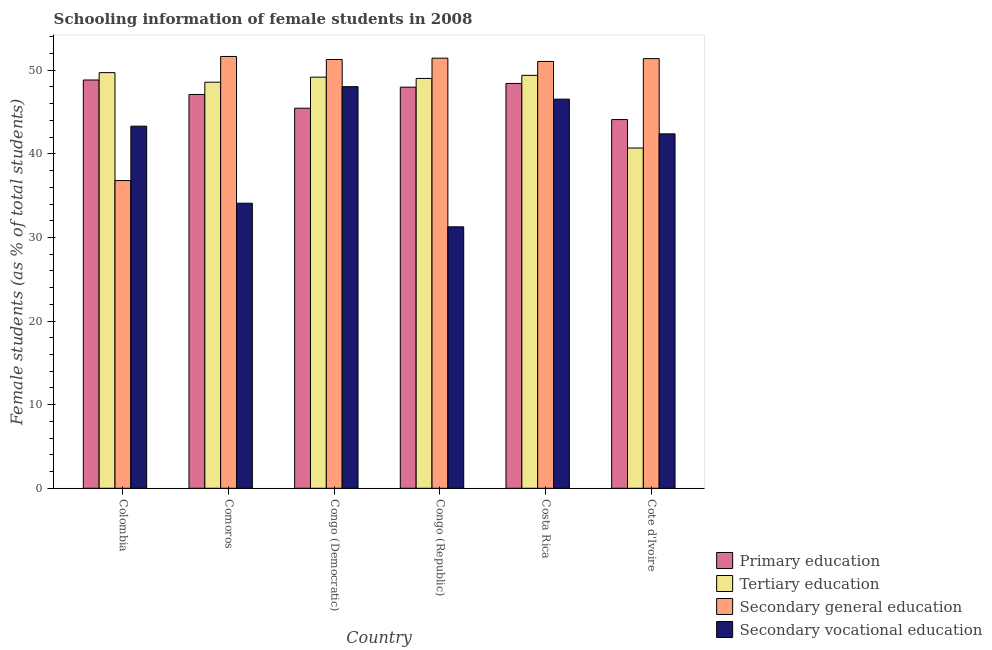How many bars are there on the 5th tick from the left?
Give a very brief answer. 4. How many bars are there on the 6th tick from the right?
Your answer should be compact. 4. What is the label of the 4th group of bars from the left?
Provide a succinct answer. Congo (Republic). What is the percentage of female students in primary education in Cote d'Ivoire?
Your answer should be compact. 44.1. Across all countries, what is the maximum percentage of female students in secondary education?
Provide a succinct answer. 51.65. Across all countries, what is the minimum percentage of female students in secondary education?
Your response must be concise. 36.81. In which country was the percentage of female students in secondary education maximum?
Provide a short and direct response. Comoros. In which country was the percentage of female students in secondary vocational education minimum?
Offer a terse response. Congo (Republic). What is the total percentage of female students in primary education in the graph?
Provide a short and direct response. 281.9. What is the difference between the percentage of female students in primary education in Comoros and that in Cote d'Ivoire?
Give a very brief answer. 3. What is the difference between the percentage of female students in tertiary education in Congo (Republic) and the percentage of female students in secondary vocational education in Comoros?
Offer a terse response. 14.92. What is the average percentage of female students in tertiary education per country?
Keep it short and to the point. 47.76. What is the difference between the percentage of female students in secondary vocational education and percentage of female students in primary education in Congo (Democratic)?
Provide a short and direct response. 2.58. In how many countries, is the percentage of female students in primary education greater than 48 %?
Keep it short and to the point. 2. What is the ratio of the percentage of female students in secondary education in Congo (Democratic) to that in Congo (Republic)?
Make the answer very short. 1. Is the percentage of female students in tertiary education in Costa Rica less than that in Cote d'Ivoire?
Give a very brief answer. No. What is the difference between the highest and the second highest percentage of female students in secondary education?
Provide a succinct answer. 0.2. What is the difference between the highest and the lowest percentage of female students in primary education?
Offer a very short reply. 4.73. In how many countries, is the percentage of female students in tertiary education greater than the average percentage of female students in tertiary education taken over all countries?
Offer a very short reply. 5. What does the 2nd bar from the left in Congo (Republic) represents?
Your answer should be compact. Tertiary education. What does the 3rd bar from the right in Cote d'Ivoire represents?
Ensure brevity in your answer.  Tertiary education. Is it the case that in every country, the sum of the percentage of female students in primary education and percentage of female students in tertiary education is greater than the percentage of female students in secondary education?
Give a very brief answer. Yes. What is the difference between two consecutive major ticks on the Y-axis?
Make the answer very short. 10. Are the values on the major ticks of Y-axis written in scientific E-notation?
Ensure brevity in your answer.  No. Does the graph contain any zero values?
Ensure brevity in your answer.  No. What is the title of the graph?
Your answer should be compact. Schooling information of female students in 2008. Does "Greece" appear as one of the legend labels in the graph?
Offer a terse response. No. What is the label or title of the Y-axis?
Make the answer very short. Female students (as % of total students). What is the Female students (as % of total students) of Primary education in Colombia?
Offer a terse response. 48.84. What is the Female students (as % of total students) in Tertiary education in Colombia?
Provide a succinct answer. 49.72. What is the Female students (as % of total students) in Secondary general education in Colombia?
Your answer should be very brief. 36.81. What is the Female students (as % of total students) of Secondary vocational education in Colombia?
Your answer should be very brief. 43.31. What is the Female students (as % of total students) in Primary education in Comoros?
Give a very brief answer. 47.1. What is the Female students (as % of total students) in Tertiary education in Comoros?
Offer a terse response. 48.58. What is the Female students (as % of total students) in Secondary general education in Comoros?
Your response must be concise. 51.65. What is the Female students (as % of total students) in Secondary vocational education in Comoros?
Keep it short and to the point. 34.1. What is the Female students (as % of total students) of Primary education in Congo (Democratic)?
Provide a succinct answer. 45.46. What is the Female students (as % of total students) of Tertiary education in Congo (Democratic)?
Give a very brief answer. 49.18. What is the Female students (as % of total students) in Secondary general education in Congo (Democratic)?
Offer a very short reply. 51.29. What is the Female students (as % of total students) in Secondary vocational education in Congo (Democratic)?
Your answer should be compact. 48.04. What is the Female students (as % of total students) of Primary education in Congo (Republic)?
Give a very brief answer. 47.98. What is the Female students (as % of total students) in Tertiary education in Congo (Republic)?
Your answer should be very brief. 49.02. What is the Female students (as % of total students) in Secondary general education in Congo (Republic)?
Ensure brevity in your answer.  51.45. What is the Female students (as % of total students) of Secondary vocational education in Congo (Republic)?
Your answer should be very brief. 31.27. What is the Female students (as % of total students) of Primary education in Costa Rica?
Keep it short and to the point. 48.42. What is the Female students (as % of total students) of Tertiary education in Costa Rica?
Your answer should be compact. 49.39. What is the Female students (as % of total students) in Secondary general education in Costa Rica?
Provide a succinct answer. 51.05. What is the Female students (as % of total students) in Secondary vocational education in Costa Rica?
Provide a succinct answer. 46.54. What is the Female students (as % of total students) in Primary education in Cote d'Ivoire?
Keep it short and to the point. 44.1. What is the Female students (as % of total students) of Tertiary education in Cote d'Ivoire?
Provide a short and direct response. 40.7. What is the Female students (as % of total students) of Secondary general education in Cote d'Ivoire?
Offer a very short reply. 51.39. What is the Female students (as % of total students) of Secondary vocational education in Cote d'Ivoire?
Keep it short and to the point. 42.39. Across all countries, what is the maximum Female students (as % of total students) in Primary education?
Provide a short and direct response. 48.84. Across all countries, what is the maximum Female students (as % of total students) in Tertiary education?
Your answer should be very brief. 49.72. Across all countries, what is the maximum Female students (as % of total students) of Secondary general education?
Your answer should be very brief. 51.65. Across all countries, what is the maximum Female students (as % of total students) of Secondary vocational education?
Offer a terse response. 48.04. Across all countries, what is the minimum Female students (as % of total students) of Primary education?
Offer a terse response. 44.1. Across all countries, what is the minimum Female students (as % of total students) in Tertiary education?
Your answer should be compact. 40.7. Across all countries, what is the minimum Female students (as % of total students) of Secondary general education?
Provide a short and direct response. 36.81. Across all countries, what is the minimum Female students (as % of total students) in Secondary vocational education?
Offer a terse response. 31.27. What is the total Female students (as % of total students) of Primary education in the graph?
Make the answer very short. 281.9. What is the total Female students (as % of total students) in Tertiary education in the graph?
Offer a very short reply. 286.58. What is the total Female students (as % of total students) in Secondary general education in the graph?
Give a very brief answer. 293.63. What is the total Female students (as % of total students) of Secondary vocational education in the graph?
Make the answer very short. 245.66. What is the difference between the Female students (as % of total students) of Primary education in Colombia and that in Comoros?
Offer a terse response. 1.73. What is the difference between the Female students (as % of total students) in Tertiary education in Colombia and that in Comoros?
Provide a short and direct response. 1.14. What is the difference between the Female students (as % of total students) in Secondary general education in Colombia and that in Comoros?
Your answer should be very brief. -14.84. What is the difference between the Female students (as % of total students) in Secondary vocational education in Colombia and that in Comoros?
Provide a short and direct response. 9.21. What is the difference between the Female students (as % of total students) in Primary education in Colombia and that in Congo (Democratic)?
Ensure brevity in your answer.  3.37. What is the difference between the Female students (as % of total students) in Tertiary education in Colombia and that in Congo (Democratic)?
Your response must be concise. 0.54. What is the difference between the Female students (as % of total students) of Secondary general education in Colombia and that in Congo (Democratic)?
Keep it short and to the point. -14.48. What is the difference between the Female students (as % of total students) of Secondary vocational education in Colombia and that in Congo (Democratic)?
Make the answer very short. -4.73. What is the difference between the Female students (as % of total students) in Primary education in Colombia and that in Congo (Republic)?
Offer a very short reply. 0.86. What is the difference between the Female students (as % of total students) of Tertiary education in Colombia and that in Congo (Republic)?
Keep it short and to the point. 0.7. What is the difference between the Female students (as % of total students) of Secondary general education in Colombia and that in Congo (Republic)?
Provide a short and direct response. -14.64. What is the difference between the Female students (as % of total students) of Secondary vocational education in Colombia and that in Congo (Republic)?
Offer a very short reply. 12.04. What is the difference between the Female students (as % of total students) in Primary education in Colombia and that in Costa Rica?
Ensure brevity in your answer.  0.41. What is the difference between the Female students (as % of total students) of Tertiary education in Colombia and that in Costa Rica?
Provide a succinct answer. 0.33. What is the difference between the Female students (as % of total students) in Secondary general education in Colombia and that in Costa Rica?
Give a very brief answer. -14.25. What is the difference between the Female students (as % of total students) of Secondary vocational education in Colombia and that in Costa Rica?
Give a very brief answer. -3.23. What is the difference between the Female students (as % of total students) of Primary education in Colombia and that in Cote d'Ivoire?
Give a very brief answer. 4.73. What is the difference between the Female students (as % of total students) of Tertiary education in Colombia and that in Cote d'Ivoire?
Offer a terse response. 9.02. What is the difference between the Female students (as % of total students) of Secondary general education in Colombia and that in Cote d'Ivoire?
Give a very brief answer. -14.59. What is the difference between the Female students (as % of total students) of Secondary vocational education in Colombia and that in Cote d'Ivoire?
Your answer should be very brief. 0.92. What is the difference between the Female students (as % of total students) of Primary education in Comoros and that in Congo (Democratic)?
Your answer should be very brief. 1.64. What is the difference between the Female students (as % of total students) of Tertiary education in Comoros and that in Congo (Democratic)?
Offer a terse response. -0.6. What is the difference between the Female students (as % of total students) of Secondary general education in Comoros and that in Congo (Democratic)?
Your response must be concise. 0.36. What is the difference between the Female students (as % of total students) of Secondary vocational education in Comoros and that in Congo (Democratic)?
Provide a short and direct response. -13.94. What is the difference between the Female students (as % of total students) in Primary education in Comoros and that in Congo (Republic)?
Offer a very short reply. -0.87. What is the difference between the Female students (as % of total students) in Tertiary education in Comoros and that in Congo (Republic)?
Provide a short and direct response. -0.45. What is the difference between the Female students (as % of total students) of Secondary general education in Comoros and that in Congo (Republic)?
Offer a very short reply. 0.2. What is the difference between the Female students (as % of total students) in Secondary vocational education in Comoros and that in Congo (Republic)?
Give a very brief answer. 2.82. What is the difference between the Female students (as % of total students) of Primary education in Comoros and that in Costa Rica?
Your answer should be compact. -1.32. What is the difference between the Female students (as % of total students) in Tertiary education in Comoros and that in Costa Rica?
Ensure brevity in your answer.  -0.81. What is the difference between the Female students (as % of total students) in Secondary general education in Comoros and that in Costa Rica?
Provide a short and direct response. 0.6. What is the difference between the Female students (as % of total students) of Secondary vocational education in Comoros and that in Costa Rica?
Your answer should be very brief. -12.45. What is the difference between the Female students (as % of total students) in Primary education in Comoros and that in Cote d'Ivoire?
Your response must be concise. 3. What is the difference between the Female students (as % of total students) of Tertiary education in Comoros and that in Cote d'Ivoire?
Ensure brevity in your answer.  7.88. What is the difference between the Female students (as % of total students) of Secondary general education in Comoros and that in Cote d'Ivoire?
Offer a terse response. 0.26. What is the difference between the Female students (as % of total students) of Secondary vocational education in Comoros and that in Cote d'Ivoire?
Your answer should be very brief. -8.3. What is the difference between the Female students (as % of total students) of Primary education in Congo (Democratic) and that in Congo (Republic)?
Your response must be concise. -2.52. What is the difference between the Female students (as % of total students) of Tertiary education in Congo (Democratic) and that in Congo (Republic)?
Your response must be concise. 0.16. What is the difference between the Female students (as % of total students) of Secondary general education in Congo (Democratic) and that in Congo (Republic)?
Give a very brief answer. -0.16. What is the difference between the Female students (as % of total students) in Secondary vocational education in Congo (Democratic) and that in Congo (Republic)?
Provide a short and direct response. 16.76. What is the difference between the Female students (as % of total students) in Primary education in Congo (Democratic) and that in Costa Rica?
Give a very brief answer. -2.96. What is the difference between the Female students (as % of total students) of Tertiary education in Congo (Democratic) and that in Costa Rica?
Give a very brief answer. -0.21. What is the difference between the Female students (as % of total students) in Secondary general education in Congo (Democratic) and that in Costa Rica?
Keep it short and to the point. 0.23. What is the difference between the Female students (as % of total students) of Secondary vocational education in Congo (Democratic) and that in Costa Rica?
Your response must be concise. 1.49. What is the difference between the Female students (as % of total students) in Primary education in Congo (Democratic) and that in Cote d'Ivoire?
Provide a short and direct response. 1.36. What is the difference between the Female students (as % of total students) of Tertiary education in Congo (Democratic) and that in Cote d'Ivoire?
Keep it short and to the point. 8.48. What is the difference between the Female students (as % of total students) in Secondary general education in Congo (Democratic) and that in Cote d'Ivoire?
Your answer should be very brief. -0.11. What is the difference between the Female students (as % of total students) of Secondary vocational education in Congo (Democratic) and that in Cote d'Ivoire?
Offer a terse response. 5.65. What is the difference between the Female students (as % of total students) in Primary education in Congo (Republic) and that in Costa Rica?
Make the answer very short. -0.44. What is the difference between the Female students (as % of total students) of Tertiary education in Congo (Republic) and that in Costa Rica?
Give a very brief answer. -0.37. What is the difference between the Female students (as % of total students) of Secondary general education in Congo (Republic) and that in Costa Rica?
Offer a terse response. 0.39. What is the difference between the Female students (as % of total students) of Secondary vocational education in Congo (Republic) and that in Costa Rica?
Your response must be concise. -15.27. What is the difference between the Female students (as % of total students) of Primary education in Congo (Republic) and that in Cote d'Ivoire?
Your answer should be compact. 3.88. What is the difference between the Female students (as % of total students) of Tertiary education in Congo (Republic) and that in Cote d'Ivoire?
Give a very brief answer. 8.32. What is the difference between the Female students (as % of total students) in Secondary general education in Congo (Republic) and that in Cote d'Ivoire?
Make the answer very short. 0.05. What is the difference between the Female students (as % of total students) of Secondary vocational education in Congo (Republic) and that in Cote d'Ivoire?
Your answer should be compact. -11.12. What is the difference between the Female students (as % of total students) in Primary education in Costa Rica and that in Cote d'Ivoire?
Make the answer very short. 4.32. What is the difference between the Female students (as % of total students) of Tertiary education in Costa Rica and that in Cote d'Ivoire?
Keep it short and to the point. 8.69. What is the difference between the Female students (as % of total students) of Secondary general education in Costa Rica and that in Cote d'Ivoire?
Keep it short and to the point. -0.34. What is the difference between the Female students (as % of total students) of Secondary vocational education in Costa Rica and that in Cote d'Ivoire?
Offer a terse response. 4.15. What is the difference between the Female students (as % of total students) of Primary education in Colombia and the Female students (as % of total students) of Tertiary education in Comoros?
Make the answer very short. 0.26. What is the difference between the Female students (as % of total students) in Primary education in Colombia and the Female students (as % of total students) in Secondary general education in Comoros?
Your answer should be compact. -2.81. What is the difference between the Female students (as % of total students) of Primary education in Colombia and the Female students (as % of total students) of Secondary vocational education in Comoros?
Provide a short and direct response. 14.74. What is the difference between the Female students (as % of total students) of Tertiary education in Colombia and the Female students (as % of total students) of Secondary general education in Comoros?
Your answer should be very brief. -1.93. What is the difference between the Female students (as % of total students) in Tertiary education in Colombia and the Female students (as % of total students) in Secondary vocational education in Comoros?
Ensure brevity in your answer.  15.62. What is the difference between the Female students (as % of total students) in Secondary general education in Colombia and the Female students (as % of total students) in Secondary vocational education in Comoros?
Your answer should be compact. 2.71. What is the difference between the Female students (as % of total students) of Primary education in Colombia and the Female students (as % of total students) of Tertiary education in Congo (Democratic)?
Keep it short and to the point. -0.34. What is the difference between the Female students (as % of total students) of Primary education in Colombia and the Female students (as % of total students) of Secondary general education in Congo (Democratic)?
Your response must be concise. -2.45. What is the difference between the Female students (as % of total students) of Primary education in Colombia and the Female students (as % of total students) of Secondary vocational education in Congo (Democratic)?
Your answer should be very brief. 0.8. What is the difference between the Female students (as % of total students) in Tertiary education in Colombia and the Female students (as % of total students) in Secondary general education in Congo (Democratic)?
Your answer should be very brief. -1.57. What is the difference between the Female students (as % of total students) of Tertiary education in Colombia and the Female students (as % of total students) of Secondary vocational education in Congo (Democratic)?
Offer a very short reply. 1.68. What is the difference between the Female students (as % of total students) in Secondary general education in Colombia and the Female students (as % of total students) in Secondary vocational education in Congo (Democratic)?
Give a very brief answer. -11.23. What is the difference between the Female students (as % of total students) of Primary education in Colombia and the Female students (as % of total students) of Tertiary education in Congo (Republic)?
Give a very brief answer. -0.19. What is the difference between the Female students (as % of total students) of Primary education in Colombia and the Female students (as % of total students) of Secondary general education in Congo (Republic)?
Provide a short and direct response. -2.61. What is the difference between the Female students (as % of total students) of Primary education in Colombia and the Female students (as % of total students) of Secondary vocational education in Congo (Republic)?
Provide a short and direct response. 17.56. What is the difference between the Female students (as % of total students) in Tertiary education in Colombia and the Female students (as % of total students) in Secondary general education in Congo (Republic)?
Your answer should be very brief. -1.73. What is the difference between the Female students (as % of total students) in Tertiary education in Colombia and the Female students (as % of total students) in Secondary vocational education in Congo (Republic)?
Offer a terse response. 18.44. What is the difference between the Female students (as % of total students) of Secondary general education in Colombia and the Female students (as % of total students) of Secondary vocational education in Congo (Republic)?
Offer a terse response. 5.53. What is the difference between the Female students (as % of total students) in Primary education in Colombia and the Female students (as % of total students) in Tertiary education in Costa Rica?
Give a very brief answer. -0.55. What is the difference between the Female students (as % of total students) of Primary education in Colombia and the Female students (as % of total students) of Secondary general education in Costa Rica?
Your answer should be very brief. -2.22. What is the difference between the Female students (as % of total students) of Primary education in Colombia and the Female students (as % of total students) of Secondary vocational education in Costa Rica?
Offer a very short reply. 2.29. What is the difference between the Female students (as % of total students) in Tertiary education in Colombia and the Female students (as % of total students) in Secondary general education in Costa Rica?
Your answer should be very brief. -1.34. What is the difference between the Female students (as % of total students) in Tertiary education in Colombia and the Female students (as % of total students) in Secondary vocational education in Costa Rica?
Make the answer very short. 3.17. What is the difference between the Female students (as % of total students) of Secondary general education in Colombia and the Female students (as % of total students) of Secondary vocational education in Costa Rica?
Your answer should be compact. -9.74. What is the difference between the Female students (as % of total students) in Primary education in Colombia and the Female students (as % of total students) in Tertiary education in Cote d'Ivoire?
Make the answer very short. 8.14. What is the difference between the Female students (as % of total students) in Primary education in Colombia and the Female students (as % of total students) in Secondary general education in Cote d'Ivoire?
Provide a short and direct response. -2.56. What is the difference between the Female students (as % of total students) of Primary education in Colombia and the Female students (as % of total students) of Secondary vocational education in Cote d'Ivoire?
Keep it short and to the point. 6.44. What is the difference between the Female students (as % of total students) of Tertiary education in Colombia and the Female students (as % of total students) of Secondary general education in Cote d'Ivoire?
Ensure brevity in your answer.  -1.68. What is the difference between the Female students (as % of total students) of Tertiary education in Colombia and the Female students (as % of total students) of Secondary vocational education in Cote d'Ivoire?
Offer a very short reply. 7.32. What is the difference between the Female students (as % of total students) of Secondary general education in Colombia and the Female students (as % of total students) of Secondary vocational education in Cote d'Ivoire?
Keep it short and to the point. -5.59. What is the difference between the Female students (as % of total students) in Primary education in Comoros and the Female students (as % of total students) in Tertiary education in Congo (Democratic)?
Offer a very short reply. -2.07. What is the difference between the Female students (as % of total students) of Primary education in Comoros and the Female students (as % of total students) of Secondary general education in Congo (Democratic)?
Give a very brief answer. -4.18. What is the difference between the Female students (as % of total students) in Primary education in Comoros and the Female students (as % of total students) in Secondary vocational education in Congo (Democratic)?
Ensure brevity in your answer.  -0.93. What is the difference between the Female students (as % of total students) in Tertiary education in Comoros and the Female students (as % of total students) in Secondary general education in Congo (Democratic)?
Provide a succinct answer. -2.71. What is the difference between the Female students (as % of total students) of Tertiary education in Comoros and the Female students (as % of total students) of Secondary vocational education in Congo (Democratic)?
Offer a very short reply. 0.54. What is the difference between the Female students (as % of total students) in Secondary general education in Comoros and the Female students (as % of total students) in Secondary vocational education in Congo (Democratic)?
Offer a terse response. 3.61. What is the difference between the Female students (as % of total students) of Primary education in Comoros and the Female students (as % of total students) of Tertiary education in Congo (Republic)?
Provide a short and direct response. -1.92. What is the difference between the Female students (as % of total students) in Primary education in Comoros and the Female students (as % of total students) in Secondary general education in Congo (Republic)?
Ensure brevity in your answer.  -4.34. What is the difference between the Female students (as % of total students) of Primary education in Comoros and the Female students (as % of total students) of Secondary vocational education in Congo (Republic)?
Give a very brief answer. 15.83. What is the difference between the Female students (as % of total students) of Tertiary education in Comoros and the Female students (as % of total students) of Secondary general education in Congo (Republic)?
Keep it short and to the point. -2.87. What is the difference between the Female students (as % of total students) in Tertiary education in Comoros and the Female students (as % of total students) in Secondary vocational education in Congo (Republic)?
Keep it short and to the point. 17.3. What is the difference between the Female students (as % of total students) in Secondary general education in Comoros and the Female students (as % of total students) in Secondary vocational education in Congo (Republic)?
Provide a short and direct response. 20.38. What is the difference between the Female students (as % of total students) of Primary education in Comoros and the Female students (as % of total students) of Tertiary education in Costa Rica?
Provide a succinct answer. -2.28. What is the difference between the Female students (as % of total students) in Primary education in Comoros and the Female students (as % of total students) in Secondary general education in Costa Rica?
Your answer should be very brief. -3.95. What is the difference between the Female students (as % of total students) of Primary education in Comoros and the Female students (as % of total students) of Secondary vocational education in Costa Rica?
Your answer should be compact. 0.56. What is the difference between the Female students (as % of total students) of Tertiary education in Comoros and the Female students (as % of total students) of Secondary general education in Costa Rica?
Your answer should be very brief. -2.48. What is the difference between the Female students (as % of total students) in Tertiary education in Comoros and the Female students (as % of total students) in Secondary vocational education in Costa Rica?
Ensure brevity in your answer.  2.03. What is the difference between the Female students (as % of total students) in Secondary general education in Comoros and the Female students (as % of total students) in Secondary vocational education in Costa Rica?
Your answer should be very brief. 5.11. What is the difference between the Female students (as % of total students) of Primary education in Comoros and the Female students (as % of total students) of Tertiary education in Cote d'Ivoire?
Offer a very short reply. 6.41. What is the difference between the Female students (as % of total students) in Primary education in Comoros and the Female students (as % of total students) in Secondary general education in Cote d'Ivoire?
Make the answer very short. -4.29. What is the difference between the Female students (as % of total students) in Primary education in Comoros and the Female students (as % of total students) in Secondary vocational education in Cote d'Ivoire?
Provide a short and direct response. 4.71. What is the difference between the Female students (as % of total students) in Tertiary education in Comoros and the Female students (as % of total students) in Secondary general education in Cote d'Ivoire?
Offer a terse response. -2.82. What is the difference between the Female students (as % of total students) of Tertiary education in Comoros and the Female students (as % of total students) of Secondary vocational education in Cote d'Ivoire?
Your answer should be compact. 6.18. What is the difference between the Female students (as % of total students) in Secondary general education in Comoros and the Female students (as % of total students) in Secondary vocational education in Cote d'Ivoire?
Ensure brevity in your answer.  9.26. What is the difference between the Female students (as % of total students) of Primary education in Congo (Democratic) and the Female students (as % of total students) of Tertiary education in Congo (Republic)?
Give a very brief answer. -3.56. What is the difference between the Female students (as % of total students) in Primary education in Congo (Democratic) and the Female students (as % of total students) in Secondary general education in Congo (Republic)?
Make the answer very short. -5.98. What is the difference between the Female students (as % of total students) of Primary education in Congo (Democratic) and the Female students (as % of total students) of Secondary vocational education in Congo (Republic)?
Offer a terse response. 14.19. What is the difference between the Female students (as % of total students) in Tertiary education in Congo (Democratic) and the Female students (as % of total students) in Secondary general education in Congo (Republic)?
Ensure brevity in your answer.  -2.27. What is the difference between the Female students (as % of total students) in Tertiary education in Congo (Democratic) and the Female students (as % of total students) in Secondary vocational education in Congo (Republic)?
Keep it short and to the point. 17.9. What is the difference between the Female students (as % of total students) of Secondary general education in Congo (Democratic) and the Female students (as % of total students) of Secondary vocational education in Congo (Republic)?
Offer a terse response. 20.01. What is the difference between the Female students (as % of total students) of Primary education in Congo (Democratic) and the Female students (as % of total students) of Tertiary education in Costa Rica?
Your response must be concise. -3.93. What is the difference between the Female students (as % of total students) in Primary education in Congo (Democratic) and the Female students (as % of total students) in Secondary general education in Costa Rica?
Make the answer very short. -5.59. What is the difference between the Female students (as % of total students) of Primary education in Congo (Democratic) and the Female students (as % of total students) of Secondary vocational education in Costa Rica?
Provide a short and direct response. -1.08. What is the difference between the Female students (as % of total students) of Tertiary education in Congo (Democratic) and the Female students (as % of total students) of Secondary general education in Costa Rica?
Keep it short and to the point. -1.88. What is the difference between the Female students (as % of total students) of Tertiary education in Congo (Democratic) and the Female students (as % of total students) of Secondary vocational education in Costa Rica?
Offer a very short reply. 2.63. What is the difference between the Female students (as % of total students) in Secondary general education in Congo (Democratic) and the Female students (as % of total students) in Secondary vocational education in Costa Rica?
Provide a succinct answer. 4.74. What is the difference between the Female students (as % of total students) of Primary education in Congo (Democratic) and the Female students (as % of total students) of Tertiary education in Cote d'Ivoire?
Your answer should be very brief. 4.76. What is the difference between the Female students (as % of total students) in Primary education in Congo (Democratic) and the Female students (as % of total students) in Secondary general education in Cote d'Ivoire?
Offer a very short reply. -5.93. What is the difference between the Female students (as % of total students) in Primary education in Congo (Democratic) and the Female students (as % of total students) in Secondary vocational education in Cote d'Ivoire?
Offer a terse response. 3.07. What is the difference between the Female students (as % of total students) in Tertiary education in Congo (Democratic) and the Female students (as % of total students) in Secondary general education in Cote d'Ivoire?
Provide a short and direct response. -2.22. What is the difference between the Female students (as % of total students) of Tertiary education in Congo (Democratic) and the Female students (as % of total students) of Secondary vocational education in Cote d'Ivoire?
Provide a succinct answer. 6.78. What is the difference between the Female students (as % of total students) of Secondary general education in Congo (Democratic) and the Female students (as % of total students) of Secondary vocational education in Cote d'Ivoire?
Keep it short and to the point. 8.89. What is the difference between the Female students (as % of total students) of Primary education in Congo (Republic) and the Female students (as % of total students) of Tertiary education in Costa Rica?
Provide a short and direct response. -1.41. What is the difference between the Female students (as % of total students) in Primary education in Congo (Republic) and the Female students (as % of total students) in Secondary general education in Costa Rica?
Your answer should be compact. -3.07. What is the difference between the Female students (as % of total students) of Primary education in Congo (Republic) and the Female students (as % of total students) of Secondary vocational education in Costa Rica?
Make the answer very short. 1.43. What is the difference between the Female students (as % of total students) of Tertiary education in Congo (Republic) and the Female students (as % of total students) of Secondary general education in Costa Rica?
Provide a short and direct response. -2.03. What is the difference between the Female students (as % of total students) in Tertiary education in Congo (Republic) and the Female students (as % of total students) in Secondary vocational education in Costa Rica?
Provide a succinct answer. 2.48. What is the difference between the Female students (as % of total students) of Secondary general education in Congo (Republic) and the Female students (as % of total students) of Secondary vocational education in Costa Rica?
Ensure brevity in your answer.  4.9. What is the difference between the Female students (as % of total students) in Primary education in Congo (Republic) and the Female students (as % of total students) in Tertiary education in Cote d'Ivoire?
Keep it short and to the point. 7.28. What is the difference between the Female students (as % of total students) of Primary education in Congo (Republic) and the Female students (as % of total students) of Secondary general education in Cote d'Ivoire?
Ensure brevity in your answer.  -3.41. What is the difference between the Female students (as % of total students) in Primary education in Congo (Republic) and the Female students (as % of total students) in Secondary vocational education in Cote d'Ivoire?
Your answer should be compact. 5.59. What is the difference between the Female students (as % of total students) of Tertiary education in Congo (Republic) and the Female students (as % of total students) of Secondary general education in Cote d'Ivoire?
Ensure brevity in your answer.  -2.37. What is the difference between the Female students (as % of total students) in Tertiary education in Congo (Republic) and the Female students (as % of total students) in Secondary vocational education in Cote d'Ivoire?
Offer a very short reply. 6.63. What is the difference between the Female students (as % of total students) of Secondary general education in Congo (Republic) and the Female students (as % of total students) of Secondary vocational education in Cote d'Ivoire?
Your answer should be compact. 9.05. What is the difference between the Female students (as % of total students) of Primary education in Costa Rica and the Female students (as % of total students) of Tertiary education in Cote d'Ivoire?
Your response must be concise. 7.73. What is the difference between the Female students (as % of total students) of Primary education in Costa Rica and the Female students (as % of total students) of Secondary general education in Cote d'Ivoire?
Provide a short and direct response. -2.97. What is the difference between the Female students (as % of total students) of Primary education in Costa Rica and the Female students (as % of total students) of Secondary vocational education in Cote d'Ivoire?
Offer a terse response. 6.03. What is the difference between the Female students (as % of total students) of Tertiary education in Costa Rica and the Female students (as % of total students) of Secondary general education in Cote d'Ivoire?
Offer a terse response. -2. What is the difference between the Female students (as % of total students) of Tertiary education in Costa Rica and the Female students (as % of total students) of Secondary vocational education in Cote d'Ivoire?
Make the answer very short. 7. What is the difference between the Female students (as % of total students) of Secondary general education in Costa Rica and the Female students (as % of total students) of Secondary vocational education in Cote d'Ivoire?
Offer a terse response. 8.66. What is the average Female students (as % of total students) in Primary education per country?
Ensure brevity in your answer.  46.98. What is the average Female students (as % of total students) of Tertiary education per country?
Offer a terse response. 47.76. What is the average Female students (as % of total students) in Secondary general education per country?
Offer a very short reply. 48.94. What is the average Female students (as % of total students) in Secondary vocational education per country?
Keep it short and to the point. 40.94. What is the difference between the Female students (as % of total students) of Primary education and Female students (as % of total students) of Tertiary education in Colombia?
Your response must be concise. -0.88. What is the difference between the Female students (as % of total students) in Primary education and Female students (as % of total students) in Secondary general education in Colombia?
Your answer should be very brief. 12.03. What is the difference between the Female students (as % of total students) of Primary education and Female students (as % of total students) of Secondary vocational education in Colombia?
Your answer should be compact. 5.52. What is the difference between the Female students (as % of total students) in Tertiary education and Female students (as % of total students) in Secondary general education in Colombia?
Keep it short and to the point. 12.91. What is the difference between the Female students (as % of total students) in Tertiary education and Female students (as % of total students) in Secondary vocational education in Colombia?
Your answer should be very brief. 6.41. What is the difference between the Female students (as % of total students) in Secondary general education and Female students (as % of total students) in Secondary vocational education in Colombia?
Your answer should be very brief. -6.5. What is the difference between the Female students (as % of total students) in Primary education and Female students (as % of total students) in Tertiary education in Comoros?
Provide a succinct answer. -1.47. What is the difference between the Female students (as % of total students) in Primary education and Female students (as % of total students) in Secondary general education in Comoros?
Your answer should be very brief. -4.55. What is the difference between the Female students (as % of total students) of Primary education and Female students (as % of total students) of Secondary vocational education in Comoros?
Your answer should be compact. 13.01. What is the difference between the Female students (as % of total students) in Tertiary education and Female students (as % of total students) in Secondary general education in Comoros?
Give a very brief answer. -3.07. What is the difference between the Female students (as % of total students) in Tertiary education and Female students (as % of total students) in Secondary vocational education in Comoros?
Provide a succinct answer. 14.48. What is the difference between the Female students (as % of total students) of Secondary general education and Female students (as % of total students) of Secondary vocational education in Comoros?
Keep it short and to the point. 17.55. What is the difference between the Female students (as % of total students) of Primary education and Female students (as % of total students) of Tertiary education in Congo (Democratic)?
Give a very brief answer. -3.72. What is the difference between the Female students (as % of total students) of Primary education and Female students (as % of total students) of Secondary general education in Congo (Democratic)?
Your answer should be very brief. -5.82. What is the difference between the Female students (as % of total students) of Primary education and Female students (as % of total students) of Secondary vocational education in Congo (Democratic)?
Your answer should be very brief. -2.58. What is the difference between the Female students (as % of total students) of Tertiary education and Female students (as % of total students) of Secondary general education in Congo (Democratic)?
Make the answer very short. -2.11. What is the difference between the Female students (as % of total students) in Tertiary education and Female students (as % of total students) in Secondary vocational education in Congo (Democratic)?
Keep it short and to the point. 1.14. What is the difference between the Female students (as % of total students) in Secondary general education and Female students (as % of total students) in Secondary vocational education in Congo (Democratic)?
Provide a short and direct response. 3.25. What is the difference between the Female students (as % of total students) of Primary education and Female students (as % of total students) of Tertiary education in Congo (Republic)?
Offer a terse response. -1.04. What is the difference between the Female students (as % of total students) in Primary education and Female students (as % of total students) in Secondary general education in Congo (Republic)?
Keep it short and to the point. -3.47. What is the difference between the Female students (as % of total students) in Primary education and Female students (as % of total students) in Secondary vocational education in Congo (Republic)?
Ensure brevity in your answer.  16.7. What is the difference between the Female students (as % of total students) of Tertiary education and Female students (as % of total students) of Secondary general education in Congo (Republic)?
Ensure brevity in your answer.  -2.42. What is the difference between the Female students (as % of total students) of Tertiary education and Female students (as % of total students) of Secondary vocational education in Congo (Republic)?
Your answer should be very brief. 17.75. What is the difference between the Female students (as % of total students) in Secondary general education and Female students (as % of total students) in Secondary vocational education in Congo (Republic)?
Offer a very short reply. 20.17. What is the difference between the Female students (as % of total students) in Primary education and Female students (as % of total students) in Tertiary education in Costa Rica?
Your response must be concise. -0.97. What is the difference between the Female students (as % of total students) in Primary education and Female students (as % of total students) in Secondary general education in Costa Rica?
Provide a succinct answer. -2.63. What is the difference between the Female students (as % of total students) of Primary education and Female students (as % of total students) of Secondary vocational education in Costa Rica?
Your answer should be compact. 1.88. What is the difference between the Female students (as % of total students) in Tertiary education and Female students (as % of total students) in Secondary general education in Costa Rica?
Provide a succinct answer. -1.66. What is the difference between the Female students (as % of total students) in Tertiary education and Female students (as % of total students) in Secondary vocational education in Costa Rica?
Provide a succinct answer. 2.84. What is the difference between the Female students (as % of total students) in Secondary general education and Female students (as % of total students) in Secondary vocational education in Costa Rica?
Give a very brief answer. 4.51. What is the difference between the Female students (as % of total students) of Primary education and Female students (as % of total students) of Tertiary education in Cote d'Ivoire?
Your answer should be compact. 3.4. What is the difference between the Female students (as % of total students) of Primary education and Female students (as % of total students) of Secondary general education in Cote d'Ivoire?
Offer a terse response. -7.29. What is the difference between the Female students (as % of total students) of Primary education and Female students (as % of total students) of Secondary vocational education in Cote d'Ivoire?
Provide a short and direct response. 1.71. What is the difference between the Female students (as % of total students) in Tertiary education and Female students (as % of total students) in Secondary general education in Cote d'Ivoire?
Your response must be concise. -10.69. What is the difference between the Female students (as % of total students) in Tertiary education and Female students (as % of total students) in Secondary vocational education in Cote d'Ivoire?
Make the answer very short. -1.69. What is the difference between the Female students (as % of total students) of Secondary general education and Female students (as % of total students) of Secondary vocational education in Cote d'Ivoire?
Your response must be concise. 9. What is the ratio of the Female students (as % of total students) of Primary education in Colombia to that in Comoros?
Your answer should be compact. 1.04. What is the ratio of the Female students (as % of total students) in Tertiary education in Colombia to that in Comoros?
Offer a very short reply. 1.02. What is the ratio of the Female students (as % of total students) in Secondary general education in Colombia to that in Comoros?
Your answer should be compact. 0.71. What is the ratio of the Female students (as % of total students) of Secondary vocational education in Colombia to that in Comoros?
Ensure brevity in your answer.  1.27. What is the ratio of the Female students (as % of total students) of Primary education in Colombia to that in Congo (Democratic)?
Offer a terse response. 1.07. What is the ratio of the Female students (as % of total students) in Secondary general education in Colombia to that in Congo (Democratic)?
Provide a succinct answer. 0.72. What is the ratio of the Female students (as % of total students) in Secondary vocational education in Colombia to that in Congo (Democratic)?
Your response must be concise. 0.9. What is the ratio of the Female students (as % of total students) in Primary education in Colombia to that in Congo (Republic)?
Provide a short and direct response. 1.02. What is the ratio of the Female students (as % of total students) of Tertiary education in Colombia to that in Congo (Republic)?
Offer a terse response. 1.01. What is the ratio of the Female students (as % of total students) in Secondary general education in Colombia to that in Congo (Republic)?
Ensure brevity in your answer.  0.72. What is the ratio of the Female students (as % of total students) of Secondary vocational education in Colombia to that in Congo (Republic)?
Your response must be concise. 1.38. What is the ratio of the Female students (as % of total students) of Primary education in Colombia to that in Costa Rica?
Provide a succinct answer. 1.01. What is the ratio of the Female students (as % of total students) in Tertiary education in Colombia to that in Costa Rica?
Give a very brief answer. 1.01. What is the ratio of the Female students (as % of total students) in Secondary general education in Colombia to that in Costa Rica?
Your response must be concise. 0.72. What is the ratio of the Female students (as % of total students) of Secondary vocational education in Colombia to that in Costa Rica?
Offer a very short reply. 0.93. What is the ratio of the Female students (as % of total students) of Primary education in Colombia to that in Cote d'Ivoire?
Give a very brief answer. 1.11. What is the ratio of the Female students (as % of total students) in Tertiary education in Colombia to that in Cote d'Ivoire?
Your answer should be very brief. 1.22. What is the ratio of the Female students (as % of total students) of Secondary general education in Colombia to that in Cote d'Ivoire?
Make the answer very short. 0.72. What is the ratio of the Female students (as % of total students) of Secondary vocational education in Colombia to that in Cote d'Ivoire?
Make the answer very short. 1.02. What is the ratio of the Female students (as % of total students) in Primary education in Comoros to that in Congo (Democratic)?
Your response must be concise. 1.04. What is the ratio of the Female students (as % of total students) of Secondary general education in Comoros to that in Congo (Democratic)?
Keep it short and to the point. 1.01. What is the ratio of the Female students (as % of total students) in Secondary vocational education in Comoros to that in Congo (Democratic)?
Your answer should be very brief. 0.71. What is the ratio of the Female students (as % of total students) in Primary education in Comoros to that in Congo (Republic)?
Keep it short and to the point. 0.98. What is the ratio of the Female students (as % of total students) of Tertiary education in Comoros to that in Congo (Republic)?
Offer a terse response. 0.99. What is the ratio of the Female students (as % of total students) of Secondary general education in Comoros to that in Congo (Republic)?
Offer a very short reply. 1. What is the ratio of the Female students (as % of total students) of Secondary vocational education in Comoros to that in Congo (Republic)?
Provide a succinct answer. 1.09. What is the ratio of the Female students (as % of total students) of Primary education in Comoros to that in Costa Rica?
Make the answer very short. 0.97. What is the ratio of the Female students (as % of total students) of Tertiary education in Comoros to that in Costa Rica?
Give a very brief answer. 0.98. What is the ratio of the Female students (as % of total students) of Secondary general education in Comoros to that in Costa Rica?
Make the answer very short. 1.01. What is the ratio of the Female students (as % of total students) in Secondary vocational education in Comoros to that in Costa Rica?
Make the answer very short. 0.73. What is the ratio of the Female students (as % of total students) in Primary education in Comoros to that in Cote d'Ivoire?
Your answer should be very brief. 1.07. What is the ratio of the Female students (as % of total students) in Tertiary education in Comoros to that in Cote d'Ivoire?
Offer a terse response. 1.19. What is the ratio of the Female students (as % of total students) in Secondary general education in Comoros to that in Cote d'Ivoire?
Ensure brevity in your answer.  1. What is the ratio of the Female students (as % of total students) of Secondary vocational education in Comoros to that in Cote d'Ivoire?
Your answer should be very brief. 0.8. What is the ratio of the Female students (as % of total students) in Primary education in Congo (Democratic) to that in Congo (Republic)?
Give a very brief answer. 0.95. What is the ratio of the Female students (as % of total students) in Tertiary education in Congo (Democratic) to that in Congo (Republic)?
Keep it short and to the point. 1. What is the ratio of the Female students (as % of total students) of Secondary vocational education in Congo (Democratic) to that in Congo (Republic)?
Offer a very short reply. 1.54. What is the ratio of the Female students (as % of total students) in Primary education in Congo (Democratic) to that in Costa Rica?
Offer a terse response. 0.94. What is the ratio of the Female students (as % of total students) in Secondary vocational education in Congo (Democratic) to that in Costa Rica?
Offer a very short reply. 1.03. What is the ratio of the Female students (as % of total students) of Primary education in Congo (Democratic) to that in Cote d'Ivoire?
Provide a succinct answer. 1.03. What is the ratio of the Female students (as % of total students) of Tertiary education in Congo (Democratic) to that in Cote d'Ivoire?
Provide a short and direct response. 1.21. What is the ratio of the Female students (as % of total students) of Secondary vocational education in Congo (Democratic) to that in Cote d'Ivoire?
Make the answer very short. 1.13. What is the ratio of the Female students (as % of total students) of Primary education in Congo (Republic) to that in Costa Rica?
Your answer should be compact. 0.99. What is the ratio of the Female students (as % of total students) in Tertiary education in Congo (Republic) to that in Costa Rica?
Provide a succinct answer. 0.99. What is the ratio of the Female students (as % of total students) of Secondary general education in Congo (Republic) to that in Costa Rica?
Keep it short and to the point. 1.01. What is the ratio of the Female students (as % of total students) in Secondary vocational education in Congo (Republic) to that in Costa Rica?
Offer a very short reply. 0.67. What is the ratio of the Female students (as % of total students) of Primary education in Congo (Republic) to that in Cote d'Ivoire?
Offer a very short reply. 1.09. What is the ratio of the Female students (as % of total students) of Tertiary education in Congo (Republic) to that in Cote d'Ivoire?
Give a very brief answer. 1.2. What is the ratio of the Female students (as % of total students) in Secondary general education in Congo (Republic) to that in Cote d'Ivoire?
Your response must be concise. 1. What is the ratio of the Female students (as % of total students) in Secondary vocational education in Congo (Republic) to that in Cote d'Ivoire?
Make the answer very short. 0.74. What is the ratio of the Female students (as % of total students) in Primary education in Costa Rica to that in Cote d'Ivoire?
Provide a short and direct response. 1.1. What is the ratio of the Female students (as % of total students) of Tertiary education in Costa Rica to that in Cote d'Ivoire?
Keep it short and to the point. 1.21. What is the ratio of the Female students (as % of total students) in Secondary general education in Costa Rica to that in Cote d'Ivoire?
Your response must be concise. 0.99. What is the ratio of the Female students (as % of total students) of Secondary vocational education in Costa Rica to that in Cote d'Ivoire?
Give a very brief answer. 1.1. What is the difference between the highest and the second highest Female students (as % of total students) of Primary education?
Offer a very short reply. 0.41. What is the difference between the highest and the second highest Female students (as % of total students) of Tertiary education?
Offer a very short reply. 0.33. What is the difference between the highest and the second highest Female students (as % of total students) in Secondary general education?
Keep it short and to the point. 0.2. What is the difference between the highest and the second highest Female students (as % of total students) of Secondary vocational education?
Your answer should be very brief. 1.49. What is the difference between the highest and the lowest Female students (as % of total students) of Primary education?
Your answer should be very brief. 4.73. What is the difference between the highest and the lowest Female students (as % of total students) of Tertiary education?
Your answer should be compact. 9.02. What is the difference between the highest and the lowest Female students (as % of total students) in Secondary general education?
Offer a terse response. 14.84. What is the difference between the highest and the lowest Female students (as % of total students) in Secondary vocational education?
Provide a succinct answer. 16.76. 